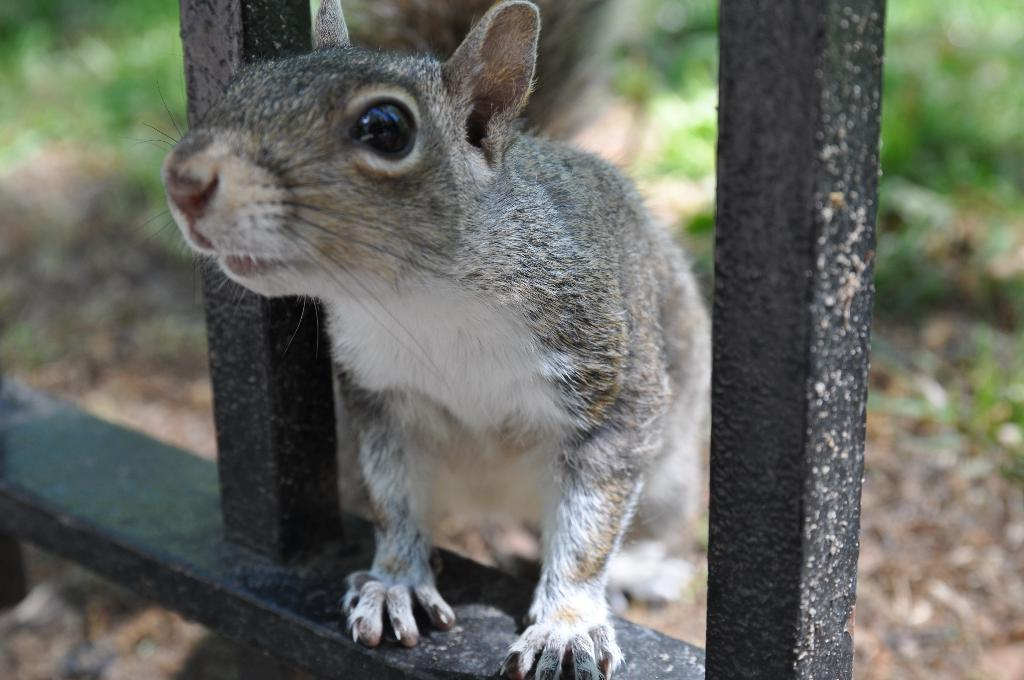What is on the railing in the image? There is an animal on the railing in the image. What can be seen in the background of the image? There are plants visible in the background of the image. What is visible at the bottom of the image? The ground is visible at the bottom of the image. What type of scent can be detected from the animal in the image? There is no indication of a scent in the image, as it is a visual medium. 